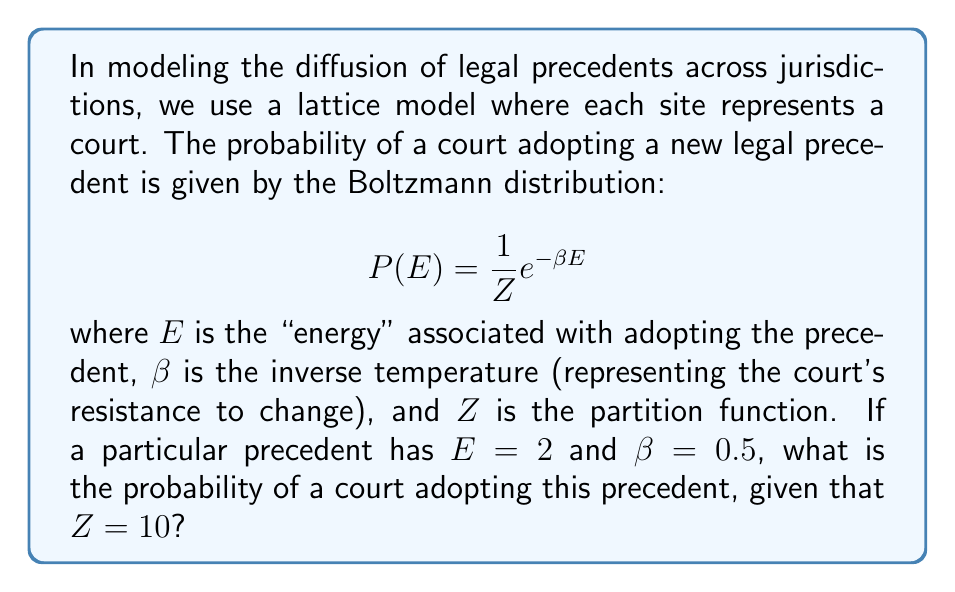What is the answer to this math problem? To solve this problem, we'll follow these steps:

1) We are given the Boltzmann distribution formula:

   $$P(E) = \frac{1}{Z} e^{-\beta E}$$

2) We know the following values:
   - $E = 2$ (energy associated with adopting the precedent)
   - $\beta = 0.5$ (inverse temperature, representing resistance to change)
   - $Z = 10$ (partition function)

3) Let's substitute these values into the formula:

   $$P(2) = \frac{1}{10} e^{-0.5 \times 2}$$

4) Simplify the exponent:

   $$P(2) = \frac{1}{10} e^{-1}$$

5) Calculate $e^{-1}$:

   $$P(2) = \frac{1}{10} \times 0.3678794$$

6) Multiply:

   $$P(2) = 0.03678794$$

Therefore, the probability of a court adopting this precedent is approximately 0.0368 or 3.68%.
Answer: $0.0368$ or $3.68\%$ 